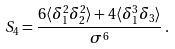<formula> <loc_0><loc_0><loc_500><loc_500>S _ { 4 } = \frac { 6 \langle \delta _ { 1 } ^ { 2 } \delta _ { 2 } ^ { 2 } \rangle + 4 \langle \delta _ { 1 } ^ { 3 } \delta _ { 3 } \rangle } { \sigma ^ { 6 } } \, .</formula> 